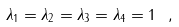<formula> <loc_0><loc_0><loc_500><loc_500>\lambda _ { 1 } = \lambda _ { 2 } = \lambda _ { 3 } = \lambda _ { 4 } = 1 \ ,</formula> 